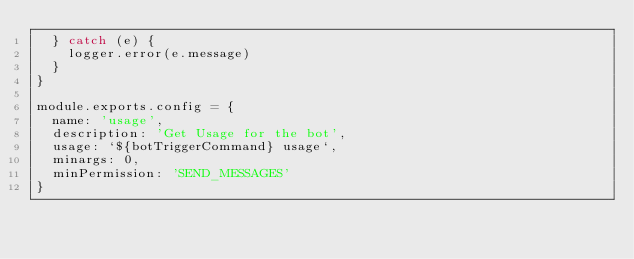<code> <loc_0><loc_0><loc_500><loc_500><_JavaScript_>  } catch (e) {
    logger.error(e.message)
  }
}

module.exports.config = {
  name: 'usage',
  description: 'Get Usage for the bot',
  usage: `${botTriggerCommand} usage`,
  minargs: 0,
  minPermission: 'SEND_MESSAGES'
}
</code> 